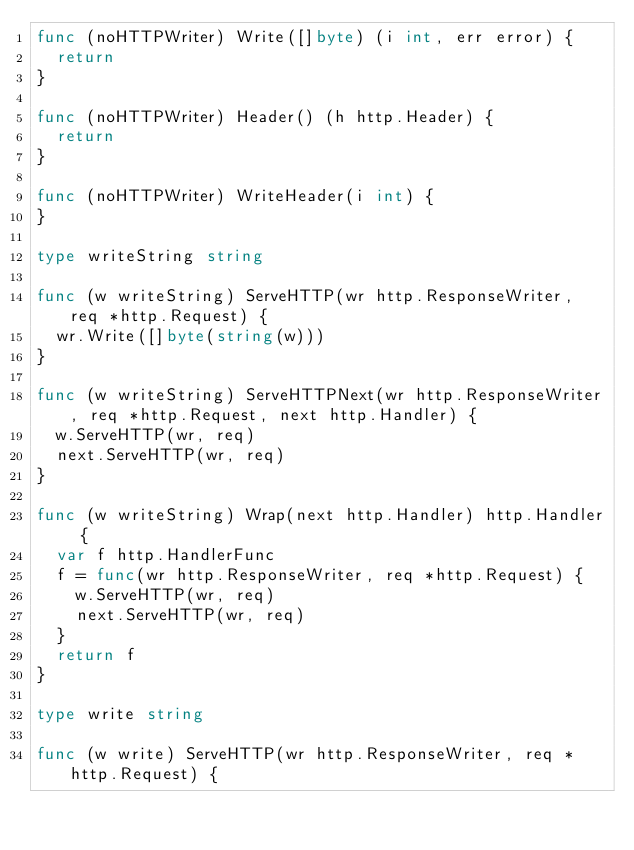<code> <loc_0><loc_0><loc_500><loc_500><_Go_>func (noHTTPWriter) Write([]byte) (i int, err error) {
	return
}

func (noHTTPWriter) Header() (h http.Header) {
	return
}

func (noHTTPWriter) WriteHeader(i int) {
}

type writeString string

func (w writeString) ServeHTTP(wr http.ResponseWriter, req *http.Request) {
	wr.Write([]byte(string(w)))
}

func (w writeString) ServeHTTPNext(wr http.ResponseWriter, req *http.Request, next http.Handler) {
	w.ServeHTTP(wr, req)
	next.ServeHTTP(wr, req)
}

func (w writeString) Wrap(next http.Handler) http.Handler {
	var f http.HandlerFunc
	f = func(wr http.ResponseWriter, req *http.Request) {
		w.ServeHTTP(wr, req)
		next.ServeHTTP(wr, req)
	}
	return f
}

type write string

func (w write) ServeHTTP(wr http.ResponseWriter, req *http.Request) {</code> 